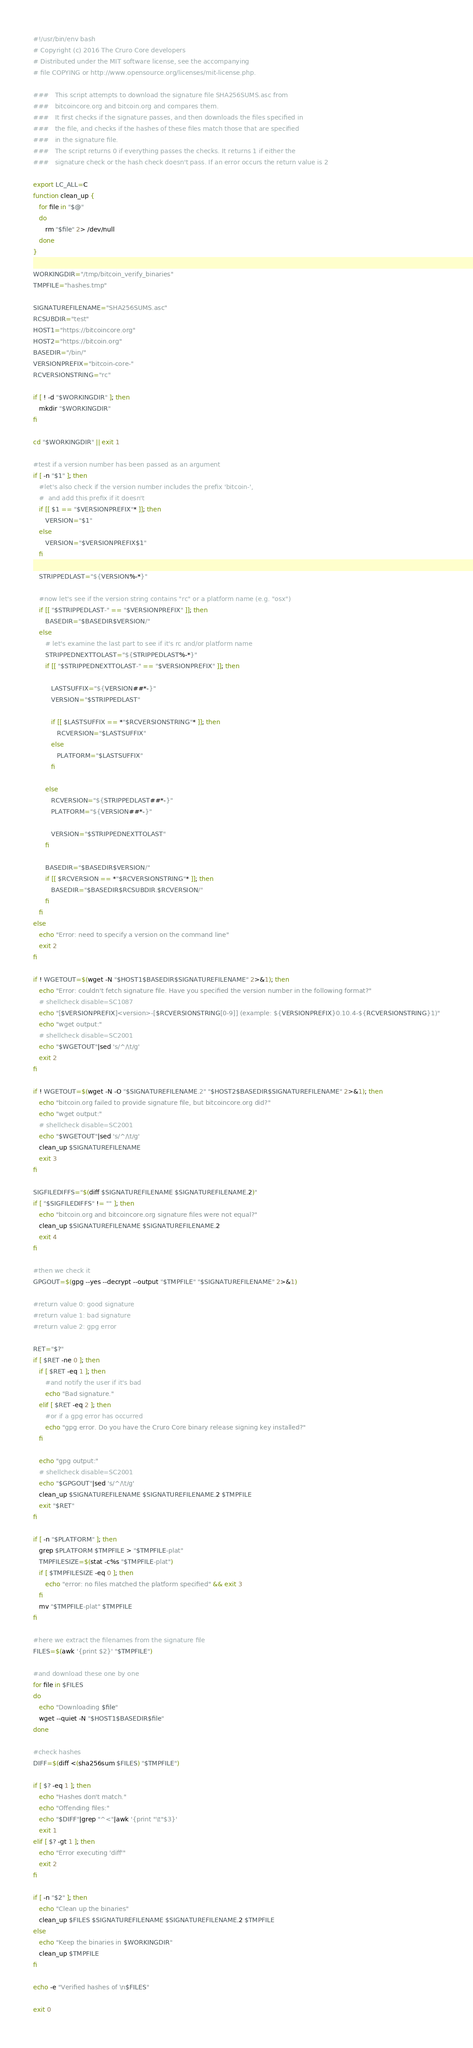<code> <loc_0><loc_0><loc_500><loc_500><_Bash_>#!/usr/bin/env bash
# Copyright (c) 2016 The Cruro Core developers
# Distributed under the MIT software license, see the accompanying
# file COPYING or http://www.opensource.org/licenses/mit-license.php.

###   This script attempts to download the signature file SHA256SUMS.asc from
###   bitcoincore.org and bitcoin.org and compares them.
###   It first checks if the signature passes, and then downloads the files specified in
###   the file, and checks if the hashes of these files match those that are specified
###   in the signature file.
###   The script returns 0 if everything passes the checks. It returns 1 if either the
###   signature check or the hash check doesn't pass. If an error occurs the return value is 2

export LC_ALL=C
function clean_up {
   for file in "$@"
   do
      rm "$file" 2> /dev/null
   done
}

WORKINGDIR="/tmp/bitcoin_verify_binaries"
TMPFILE="hashes.tmp"

SIGNATUREFILENAME="SHA256SUMS.asc"
RCSUBDIR="test"
HOST1="https://bitcoincore.org"
HOST2="https://bitcoin.org"
BASEDIR="/bin/"
VERSIONPREFIX="bitcoin-core-"
RCVERSIONSTRING="rc"

if [ ! -d "$WORKINGDIR" ]; then
   mkdir "$WORKINGDIR"
fi

cd "$WORKINGDIR" || exit 1

#test if a version number has been passed as an argument
if [ -n "$1" ]; then
   #let's also check if the version number includes the prefix 'bitcoin-',
   #  and add this prefix if it doesn't
   if [[ $1 == "$VERSIONPREFIX"* ]]; then
      VERSION="$1"
   else
      VERSION="$VERSIONPREFIX$1"
   fi

   STRIPPEDLAST="${VERSION%-*}"

   #now let's see if the version string contains "rc" or a platform name (e.g. "osx")
   if [[ "$STRIPPEDLAST-" == "$VERSIONPREFIX" ]]; then
      BASEDIR="$BASEDIR$VERSION/"
   else
      # let's examine the last part to see if it's rc and/or platform name
      STRIPPEDNEXTTOLAST="${STRIPPEDLAST%-*}"
      if [[ "$STRIPPEDNEXTTOLAST-" == "$VERSIONPREFIX" ]]; then

         LASTSUFFIX="${VERSION##*-}"
         VERSION="$STRIPPEDLAST"

         if [[ $LASTSUFFIX == *"$RCVERSIONSTRING"* ]]; then
            RCVERSION="$LASTSUFFIX"
         else
            PLATFORM="$LASTSUFFIX"
         fi

      else
         RCVERSION="${STRIPPEDLAST##*-}"
         PLATFORM="${VERSION##*-}"

         VERSION="$STRIPPEDNEXTTOLAST"
      fi

      BASEDIR="$BASEDIR$VERSION/"
      if [[ $RCVERSION == *"$RCVERSIONSTRING"* ]]; then
         BASEDIR="$BASEDIR$RCSUBDIR.$RCVERSION/"
      fi
   fi
else
   echo "Error: need to specify a version on the command line"
   exit 2
fi

if ! WGETOUT=$(wget -N "$HOST1$BASEDIR$SIGNATUREFILENAME" 2>&1); then
   echo "Error: couldn't fetch signature file. Have you specified the version number in the following format?"
   # shellcheck disable=SC1087
   echo "[$VERSIONPREFIX]<version>-[$RCVERSIONSTRING[0-9]] (example: ${VERSIONPREFIX}0.10.4-${RCVERSIONSTRING}1)"
   echo "wget output:"
   # shellcheck disable=SC2001
   echo "$WGETOUT"|sed 's/^/\t/g'
   exit 2
fi

if ! WGETOUT=$(wget -N -O "$SIGNATUREFILENAME.2" "$HOST2$BASEDIR$SIGNATUREFILENAME" 2>&1); then
   echo "bitcoin.org failed to provide signature file, but bitcoincore.org did?"
   echo "wget output:"
   # shellcheck disable=SC2001
   echo "$WGETOUT"|sed 's/^/\t/g'
   clean_up $SIGNATUREFILENAME
   exit 3
fi

SIGFILEDIFFS="$(diff $SIGNATUREFILENAME $SIGNATUREFILENAME.2)"
if [ "$SIGFILEDIFFS" != "" ]; then
   echo "bitcoin.org and bitcoincore.org signature files were not equal?"
   clean_up $SIGNATUREFILENAME $SIGNATUREFILENAME.2
   exit 4
fi

#then we check it
GPGOUT=$(gpg --yes --decrypt --output "$TMPFILE" "$SIGNATUREFILENAME" 2>&1)

#return value 0: good signature
#return value 1: bad signature
#return value 2: gpg error

RET="$?"
if [ $RET -ne 0 ]; then
   if [ $RET -eq 1 ]; then
      #and notify the user if it's bad
      echo "Bad signature."
   elif [ $RET -eq 2 ]; then
      #or if a gpg error has occurred
      echo "gpg error. Do you have the Cruro Core binary release signing key installed?"
   fi

   echo "gpg output:"
   # shellcheck disable=SC2001
   echo "$GPGOUT"|sed 's/^/\t/g'
   clean_up $SIGNATUREFILENAME $SIGNATUREFILENAME.2 $TMPFILE
   exit "$RET"
fi

if [ -n "$PLATFORM" ]; then
   grep $PLATFORM $TMPFILE > "$TMPFILE-plat"
   TMPFILESIZE=$(stat -c%s "$TMPFILE-plat")
   if [ $TMPFILESIZE -eq 0 ]; then
      echo "error: no files matched the platform specified" && exit 3
   fi
   mv "$TMPFILE-plat" $TMPFILE
fi

#here we extract the filenames from the signature file
FILES=$(awk '{print $2}' "$TMPFILE")

#and download these one by one
for file in $FILES
do
   echo "Downloading $file"
   wget --quiet -N "$HOST1$BASEDIR$file"
done

#check hashes
DIFF=$(diff <(sha256sum $FILES) "$TMPFILE")

if [ $? -eq 1 ]; then
   echo "Hashes don't match."
   echo "Offending files:"
   echo "$DIFF"|grep "^<"|awk '{print "\t"$3}'
   exit 1
elif [ $? -gt 1 ]; then
   echo "Error executing 'diff'"
   exit 2
fi

if [ -n "$2" ]; then
   echo "Clean up the binaries"
   clean_up $FILES $SIGNATUREFILENAME $SIGNATUREFILENAME.2 $TMPFILE
else
   echo "Keep the binaries in $WORKINGDIR"
   clean_up $TMPFILE
fi

echo -e "Verified hashes of \n$FILES"

exit 0
</code> 